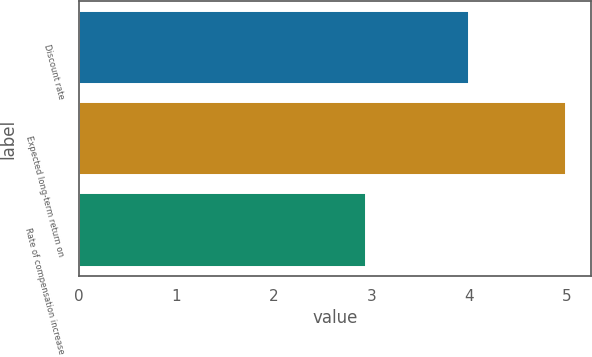<chart> <loc_0><loc_0><loc_500><loc_500><bar_chart><fcel>Discount rate<fcel>Expected long-term return on<fcel>Rate of compensation increase<nl><fcel>4<fcel>5<fcel>2.95<nl></chart> 